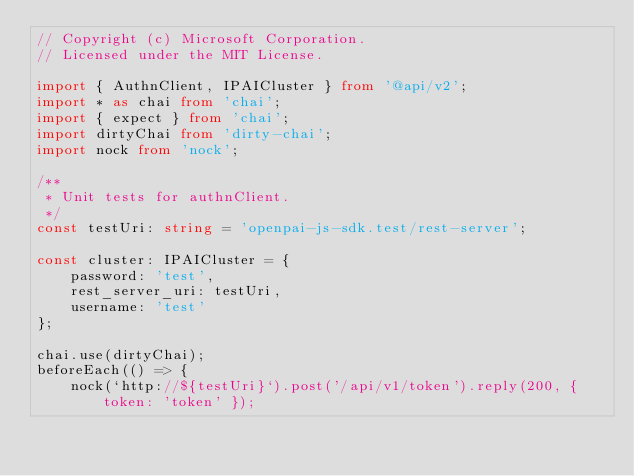<code> <loc_0><loc_0><loc_500><loc_500><_TypeScript_>// Copyright (c) Microsoft Corporation.
// Licensed under the MIT License.

import { AuthnClient, IPAICluster } from '@api/v2';
import * as chai from 'chai';
import { expect } from 'chai';
import dirtyChai from 'dirty-chai';
import nock from 'nock';

/**
 * Unit tests for authnClient.
 */
const testUri: string = 'openpai-js-sdk.test/rest-server';

const cluster: IPAICluster = {
    password: 'test',
    rest_server_uri: testUri,
    username: 'test'
};

chai.use(dirtyChai);
beforeEach(() => {
    nock(`http://${testUri}`).post('/api/v1/token').reply(200, { token: 'token' });</code> 